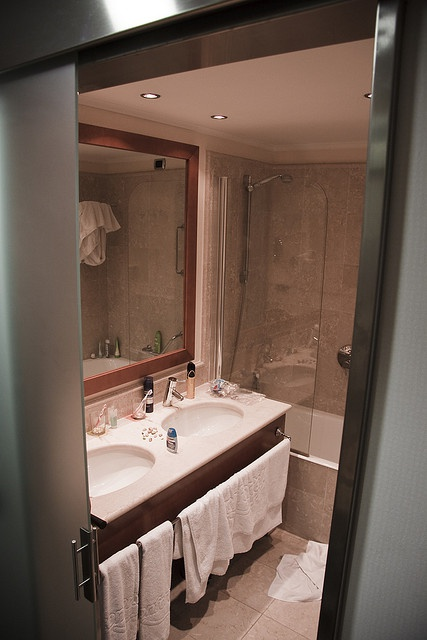Describe the objects in this image and their specific colors. I can see sink in black, lightgray, and tan tones, cup in black, tan, and salmon tones, cup in black, tan, salmon, and lightgray tones, and toothbrush in black, lightpink, lightgray, darkgray, and gray tones in this image. 